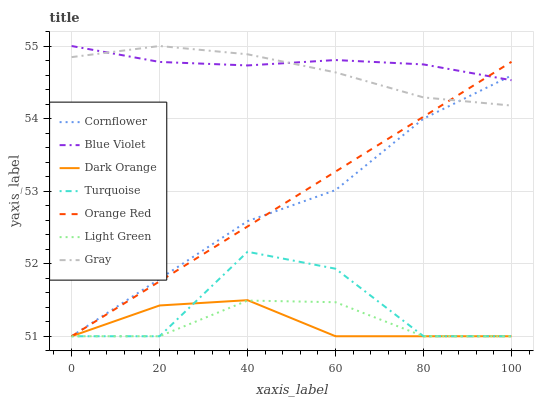Does Turquoise have the minimum area under the curve?
Answer yes or no. No. Does Turquoise have the maximum area under the curve?
Answer yes or no. No. Is Dark Orange the smoothest?
Answer yes or no. No. Is Dark Orange the roughest?
Answer yes or no. No. Does Gray have the lowest value?
Answer yes or no. No. Does Turquoise have the highest value?
Answer yes or no. No. Is Light Green less than Gray?
Answer yes or no. Yes. Is Blue Violet greater than Light Green?
Answer yes or no. Yes. Does Light Green intersect Gray?
Answer yes or no. No. 